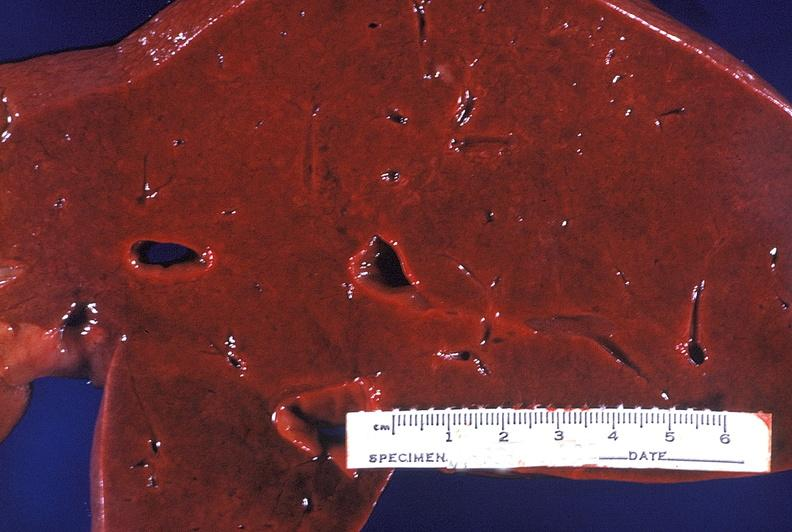does yellow color show normal liver?
Answer the question using a single word or phrase. No 